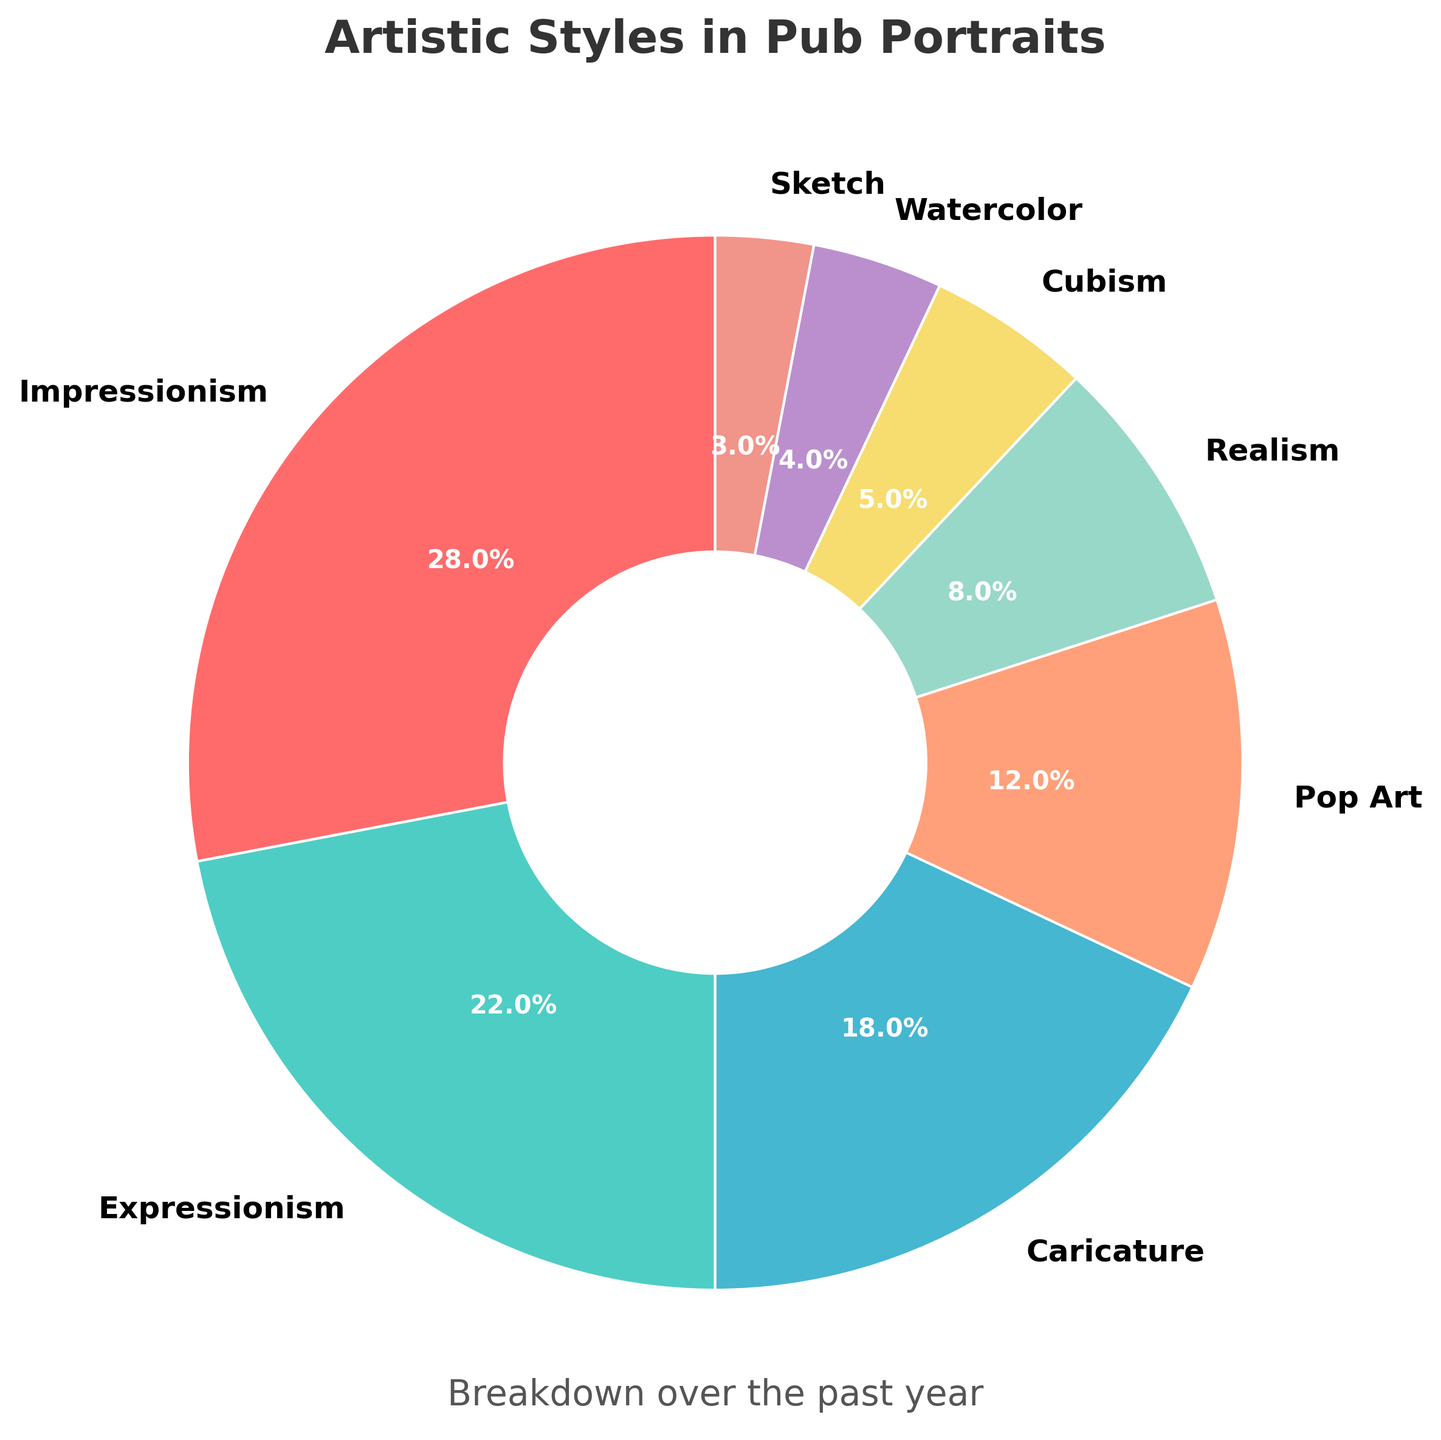Which artistic style is the most commonly used in pub portraits? By looking at the figure, we can see that the largest segment in the pie chart belongs to Impressionism.
Answer: Impressionism How many percentage points greater is Impressionism compared to Cubism? Impressionism has 28% and Cubism has 5%. The difference between them is 28% - 5% = 23%.
Answer: 23% Which two styles combined make up the largest proportion of artistic styles used? Impressionism makes up 28% and Expressionism makes up 22%. Adding them gives 28% + 22% = 50%, which is the highest combined percentage in the chart.
Answer: Impressionism and Expressionism What is the least commonly used artistic style in pub portraits? By inspecting the chart, the smallest segment belongs to Sketch.
Answer: Sketch What is the total percentage of portraits done in Caricature, Pop Art, and Watercolor combined? According to the chart, Caricature is 18%, Pop Art is 12%, and Watercolor is 4%. Adding these gives 18% + 12% + 4% = 34%.
Answer: 34% How does the percentage of Expressionism compare to that of Realism? The chart shows that Expressionism is 22% and Realism is 8%. Expressionism is 22% - 8% = 14% more than Realism.
Answer: 14% If we combine the percentages of Cubism and Watercolor, does it surpass the percentage of Pop Art? Cubism is 5% and Watercolor is 4%. Their combined percentage is 5% + 4% = 9%. This is less than Pop Art, which is 12%.
Answer: No How much greater is the combined percentage of Impressionism and Realism compared to Caricature? Impressionism and Realism together make 28% + 8% = 36%. Caricature is 18%. The difference is 36% - 18% = 18%.
Answer: 18% What is the median percentage of all the artistic styles used? To find the median percentage, list the percentages in ascending order: 3%, 4%, 5%, 8%, 12%, 18%, 22%, 28%. Since there are 8 values, the median is the average of the 4th and 5th values: (8% + 12%) / 2 = 10%.
Answer: 10% Does the sum of the percentages for Realism, Cubism, Watercolor, and Sketch add up to more than that of Impressionism alone? Realism is 8%, Cubism is 5%, Watercolor is 4%, and Sketch is 3%. Their total is 8% + 5% + 4% + 3% = 20%. Impressionism alone is 28%. 20% < 28%, so their sum does not surpass Impressionism.
Answer: No 